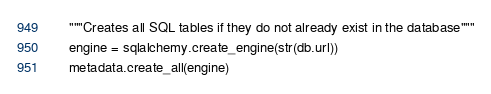Convert code to text. <code><loc_0><loc_0><loc_500><loc_500><_Python_>    """Creates all SQL tables if they do not already exist in the database"""
    engine = sqlalchemy.create_engine(str(db.url))
    metadata.create_all(engine)
</code> 